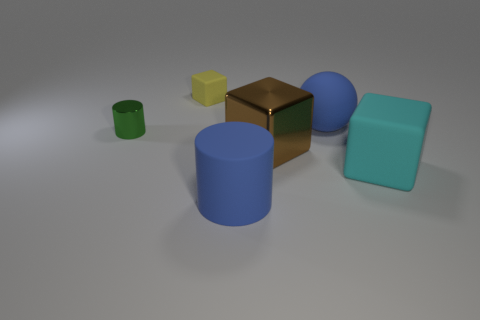Besides blue, what other colors are present in the objects? Besides blue, there is a golden object and two objects - one in pale green and another in a teal-like color. All are presented with a matte finish. 